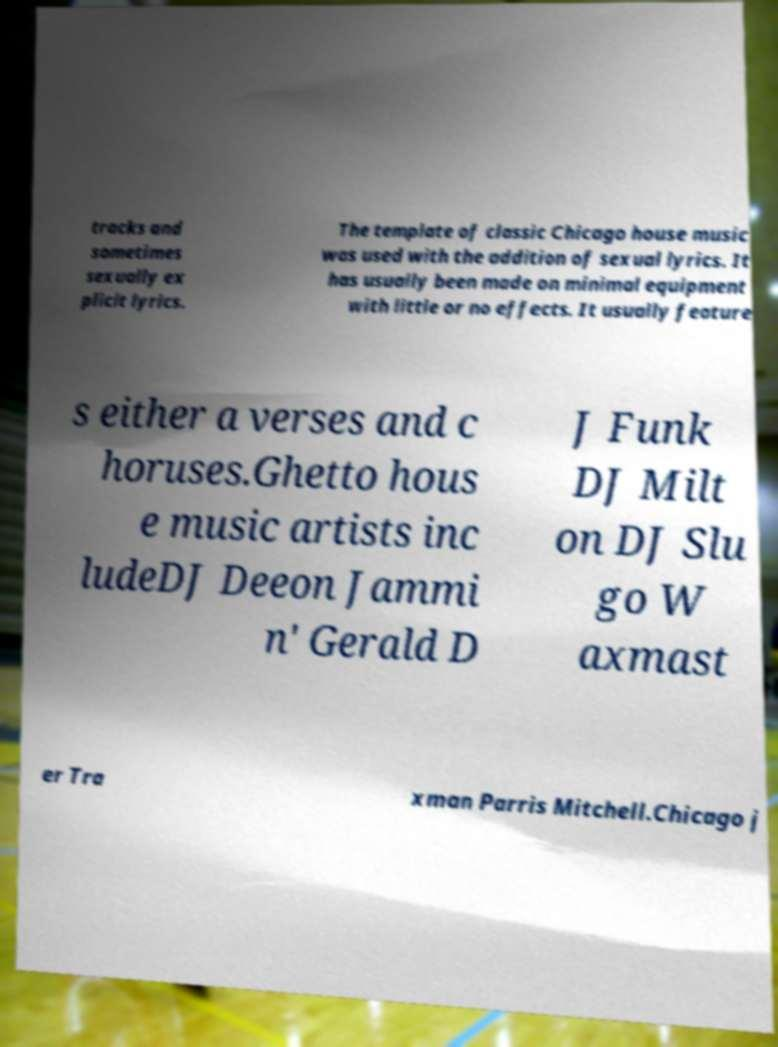What messages or text are displayed in this image? I need them in a readable, typed format. tracks and sometimes sexually ex plicit lyrics. The template of classic Chicago house music was used with the addition of sexual lyrics. It has usually been made on minimal equipment with little or no effects. It usually feature s either a verses and c horuses.Ghetto hous e music artists inc ludeDJ Deeon Jammi n' Gerald D J Funk DJ Milt on DJ Slu go W axmast er Tra xman Parris Mitchell.Chicago j 